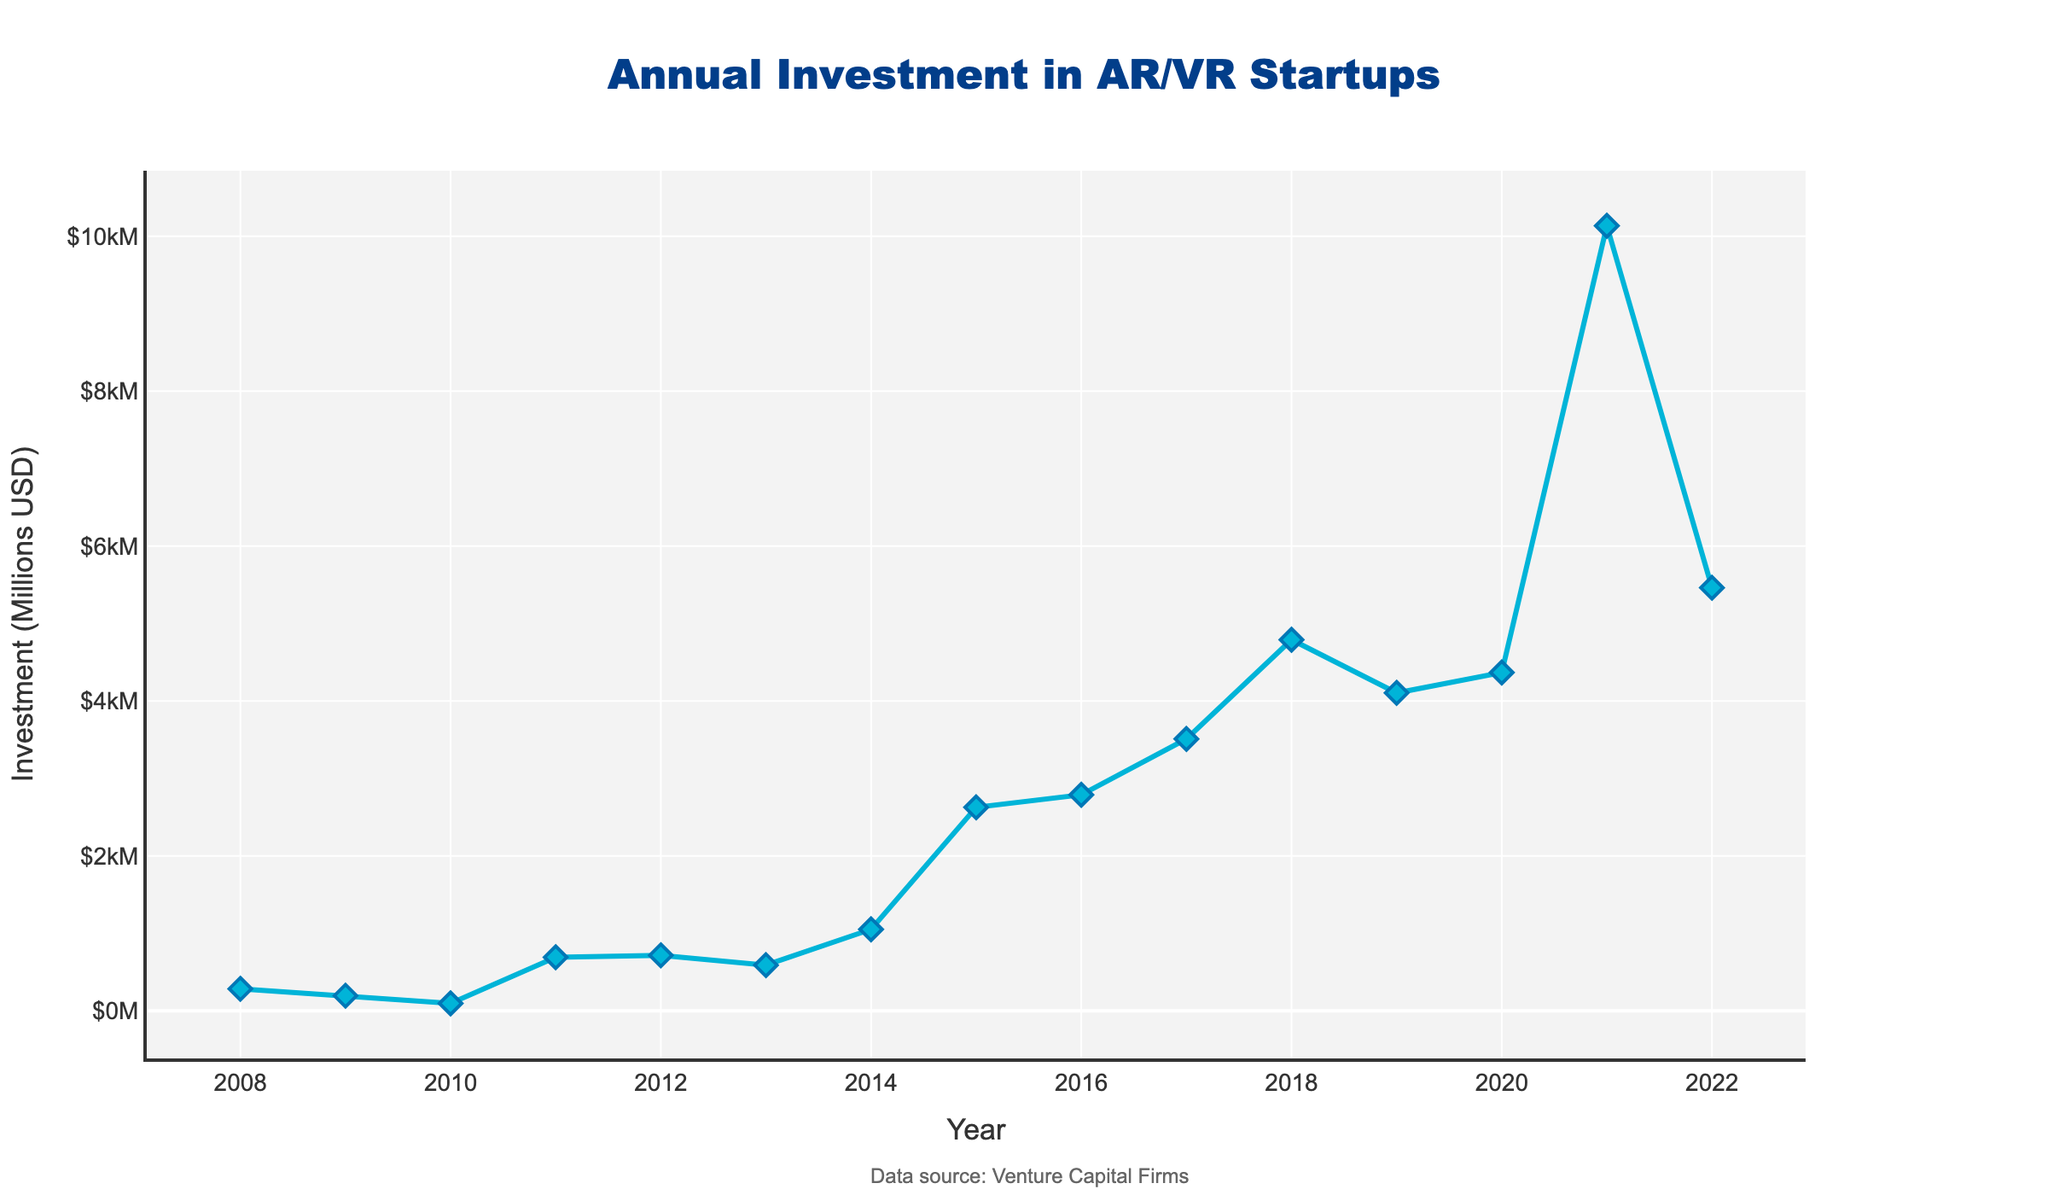what year had the highest investment in AR/VR startups? The highest point on the line chart represents the year with the highest investment. Looking at the figure, this peak is at $10,136 million in 2021.
Answer: 2021 In which year did the investment increase the most compared to the previous year? To find the largest increase, we need to compare the year-over-year differences in investment. By examining the differences, the increase from $4,368 million in 2020 to $10,136 million in 2021 is the largest.
Answer: 2021 What is the average annual investment over the last 5 years? The last 5 years are 2018 to 2022. Summing the investment for these years: 4791 + 4105 + 4368 + 10136 + 5462, the total investment is $28,862 million. Dividing by 5 gives the average. So, 28862 / 5 = 5772.4 million.
Answer: 5772.4 million USD During which five-year period was the investment growth the largest? We calculate the total investments for three 5-year periods: 2008-2012, 2013-2017, and 2018-2022. The sums are $1,983 million, $10,511 million, and $28,862 million, respectively. The largest growth occurred from 2013-2017 to 2018-2022.
Answer: 2018-2022 Between which consecutive years did the investment decrease? We need to compare the yearly investments to determine any drops. Years with decreases are 2008 to 2009, 2012 to 2013, and 2018 to 2019.
Answer: 2008-2009, 2012-2013, 2018-2019 What is the median annual investment over the entire period? Listing the investments in ascending order and finding the middle value: 96, 195, 284, 590, 692, 716, 1052, 2627, 2789, 3510, 4105, 4368, 4791, 5462, 10136. The median is the 8th value in this list, which is 2627.
Answer: 2627 million USD By how much did the investment increase from 2008 to 2022? Subtract the investment in 2008 ($284 million) from the investment in 2022 ($5462 million). The difference is 5462 - 284 = 5178 million USD.
Answer: 5178 million USD Which year between 2010 and 2015 had the lowest investment? Reviewing the investment numbers from 2010 to 2015, the lowest point is $96 million in 2010.
Answer: 2010 How many years had investments exceeding $1 billion? An investment exceeding $1 billion means more than $1000 million. The years with investments over $1000 million are 2014, 2015, 2016, 2017, 2018, 2019, 2020, 2021, and 2022, totaling 9 years.
Answer: 9 